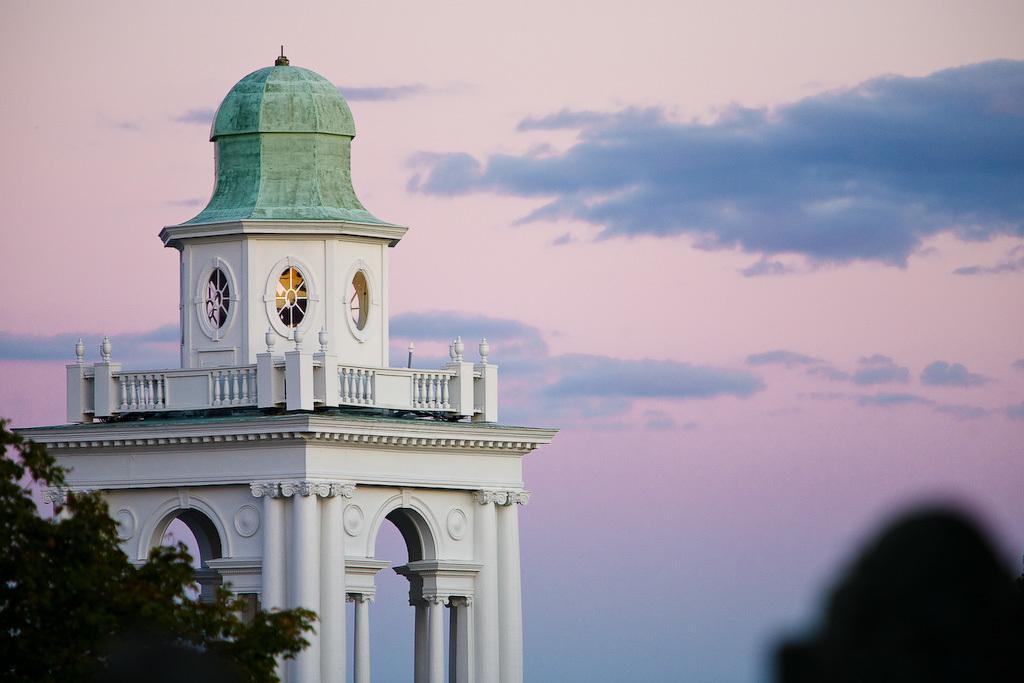How would you summarize this image in a sentence or two? In this image there is a white color building on the left side. There is a tree on the left side. There is some shadow on the right bottom. There is a sky. 